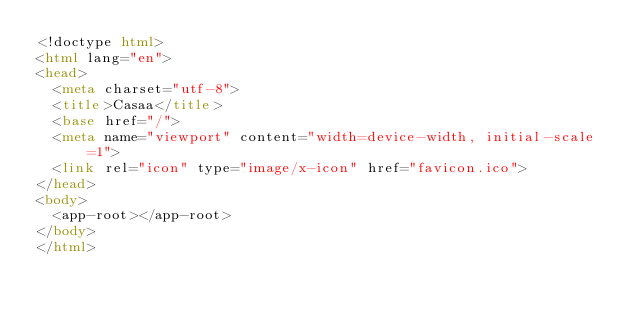Convert code to text. <code><loc_0><loc_0><loc_500><loc_500><_HTML_><!doctype html>
<html lang="en">
<head>
  <meta charset="utf-8">
  <title>Casaa</title>
  <base href="/">
  <meta name="viewport" content="width=device-width, initial-scale=1">
  <link rel="icon" type="image/x-icon" href="favicon.ico">
</head>
<body>
  <app-root></app-root>
</body>
</html>
</code> 